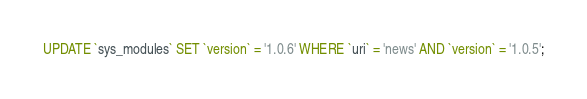<code> <loc_0><loc_0><loc_500><loc_500><_SQL_>

UPDATE `sys_modules` SET `version` = '1.0.6' WHERE `uri` = 'news' AND `version` = '1.0.5';

</code> 